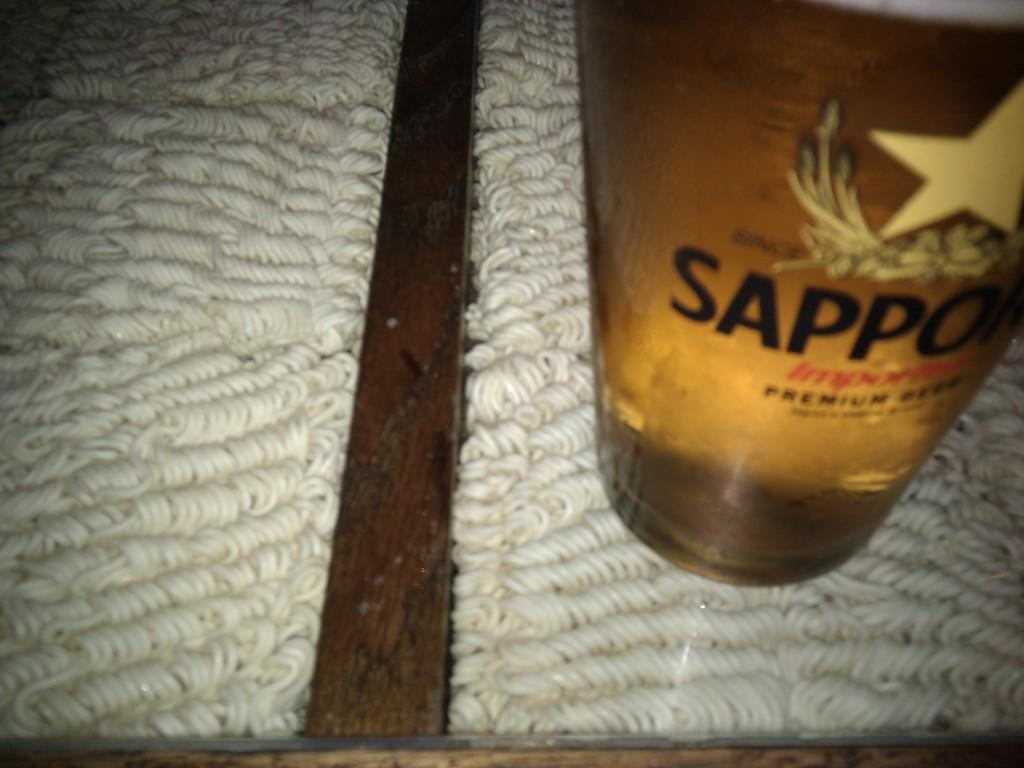<image>
Relay a brief, clear account of the picture shown. A glass of beer with writing that says Sapporo. 